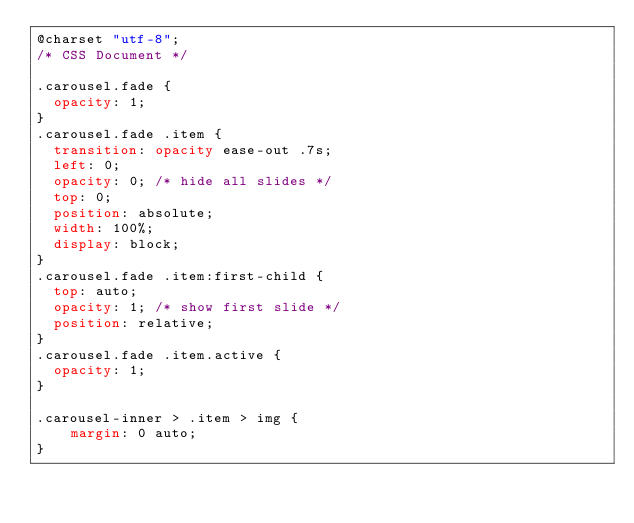<code> <loc_0><loc_0><loc_500><loc_500><_CSS_>@charset "utf-8";
/* CSS Document */

.carousel.fade {
	opacity: 1;
}
.carousel.fade .item {
	transition: opacity ease-out .7s;
	left: 0;
	opacity: 0; /* hide all slides */
	top: 0;
	position: absolute;
	width: 100%;
	display: block;
}
.carousel.fade .item:first-child {
	top: auto;
	opacity: 1; /* show first slide */
	position: relative;
}
.carousel.fade .item.active {
	opacity: 1;
}

.carousel-inner > .item > img {
    margin: 0 auto;
}</code> 